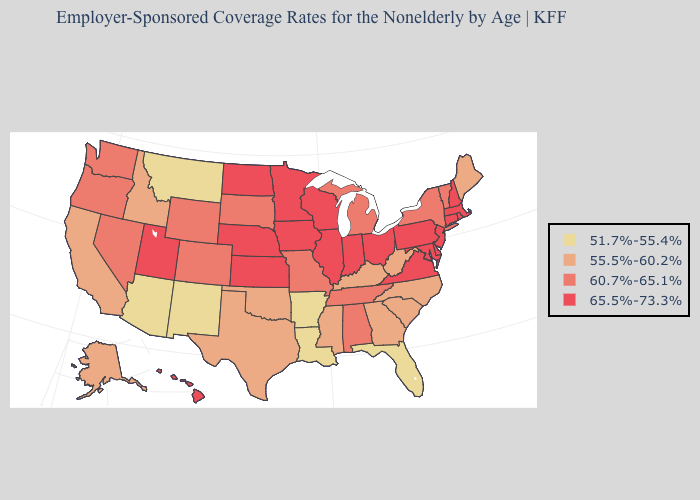Among the states that border Oregon , which have the highest value?
Quick response, please. Nevada, Washington. Does the first symbol in the legend represent the smallest category?
Quick response, please. Yes. What is the highest value in the USA?
Be succinct. 65.5%-73.3%. Name the states that have a value in the range 65.5%-73.3%?
Write a very short answer. Connecticut, Delaware, Hawaii, Illinois, Indiana, Iowa, Kansas, Maryland, Massachusetts, Minnesota, Nebraska, New Hampshire, New Jersey, North Dakota, Ohio, Pennsylvania, Rhode Island, Utah, Virginia, Wisconsin. What is the value of Iowa?
Keep it brief. 65.5%-73.3%. Does Utah have a higher value than Georgia?
Be succinct. Yes. Does Michigan have the lowest value in the USA?
Answer briefly. No. Which states have the lowest value in the USA?
Concise answer only. Arizona, Arkansas, Florida, Louisiana, Montana, New Mexico. Name the states that have a value in the range 60.7%-65.1%?
Give a very brief answer. Alabama, Colorado, Michigan, Missouri, Nevada, New York, Oregon, South Dakota, Tennessee, Vermont, Washington, Wyoming. What is the value of Delaware?
Be succinct. 65.5%-73.3%. Name the states that have a value in the range 51.7%-55.4%?
Write a very short answer. Arizona, Arkansas, Florida, Louisiana, Montana, New Mexico. What is the value of Delaware?
Answer briefly. 65.5%-73.3%. Among the states that border Arkansas , which have the highest value?
Be succinct. Missouri, Tennessee. Does Mississippi have a higher value than New York?
Answer briefly. No. Does South Dakota have a higher value than North Carolina?
Keep it brief. Yes. 